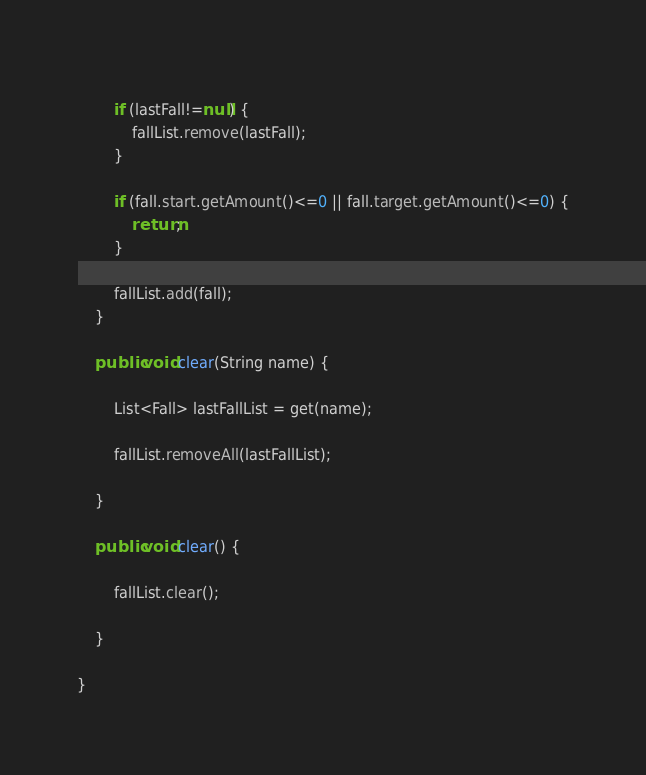Convert code to text. <code><loc_0><loc_0><loc_500><loc_500><_Java_>		
		if (lastFall!=null) {
			fallList.remove(lastFall);			
		}
				
		if (fall.start.getAmount()<=0 || fall.target.getAmount()<=0) {
			return;
		}
		
		fallList.add(fall);
	}

	public void clear(String name) {
		
		List<Fall> lastFallList = get(name);
		
		fallList.removeAll(lastFallList);
		
	}
	
	public void clear() {
		
		fallList.clear();
		
	}
	
}
</code> 